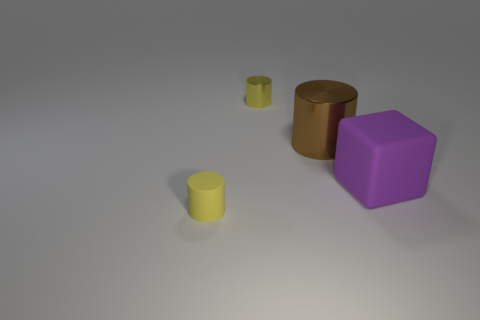The rubber cylinder that is the same color as the small metallic object is what size?
Make the answer very short. Small. Are there fewer purple rubber cubes behind the large brown metal cylinder than yellow cylinders behind the tiny rubber cylinder?
Provide a succinct answer. Yes. Is there any other thing that is the same color as the matte cube?
Your answer should be compact. No. There is a big brown shiny object; what shape is it?
Provide a short and direct response. Cylinder. What is the color of the cylinder that is the same material as the large brown object?
Offer a terse response. Yellow. Is the number of big cubes greater than the number of small red shiny things?
Ensure brevity in your answer.  Yes. Are any small gray spheres visible?
Make the answer very short. No. The small object in front of the small cylinder that is behind the purple matte object is what shape?
Give a very brief answer. Cylinder. What number of things are tiny blue matte objects or objects that are in front of the brown cylinder?
Your response must be concise. 2. There is a tiny cylinder that is on the right side of the yellow thing that is on the left side of the yellow object that is behind the large brown metal cylinder; what is its color?
Your answer should be very brief. Yellow. 